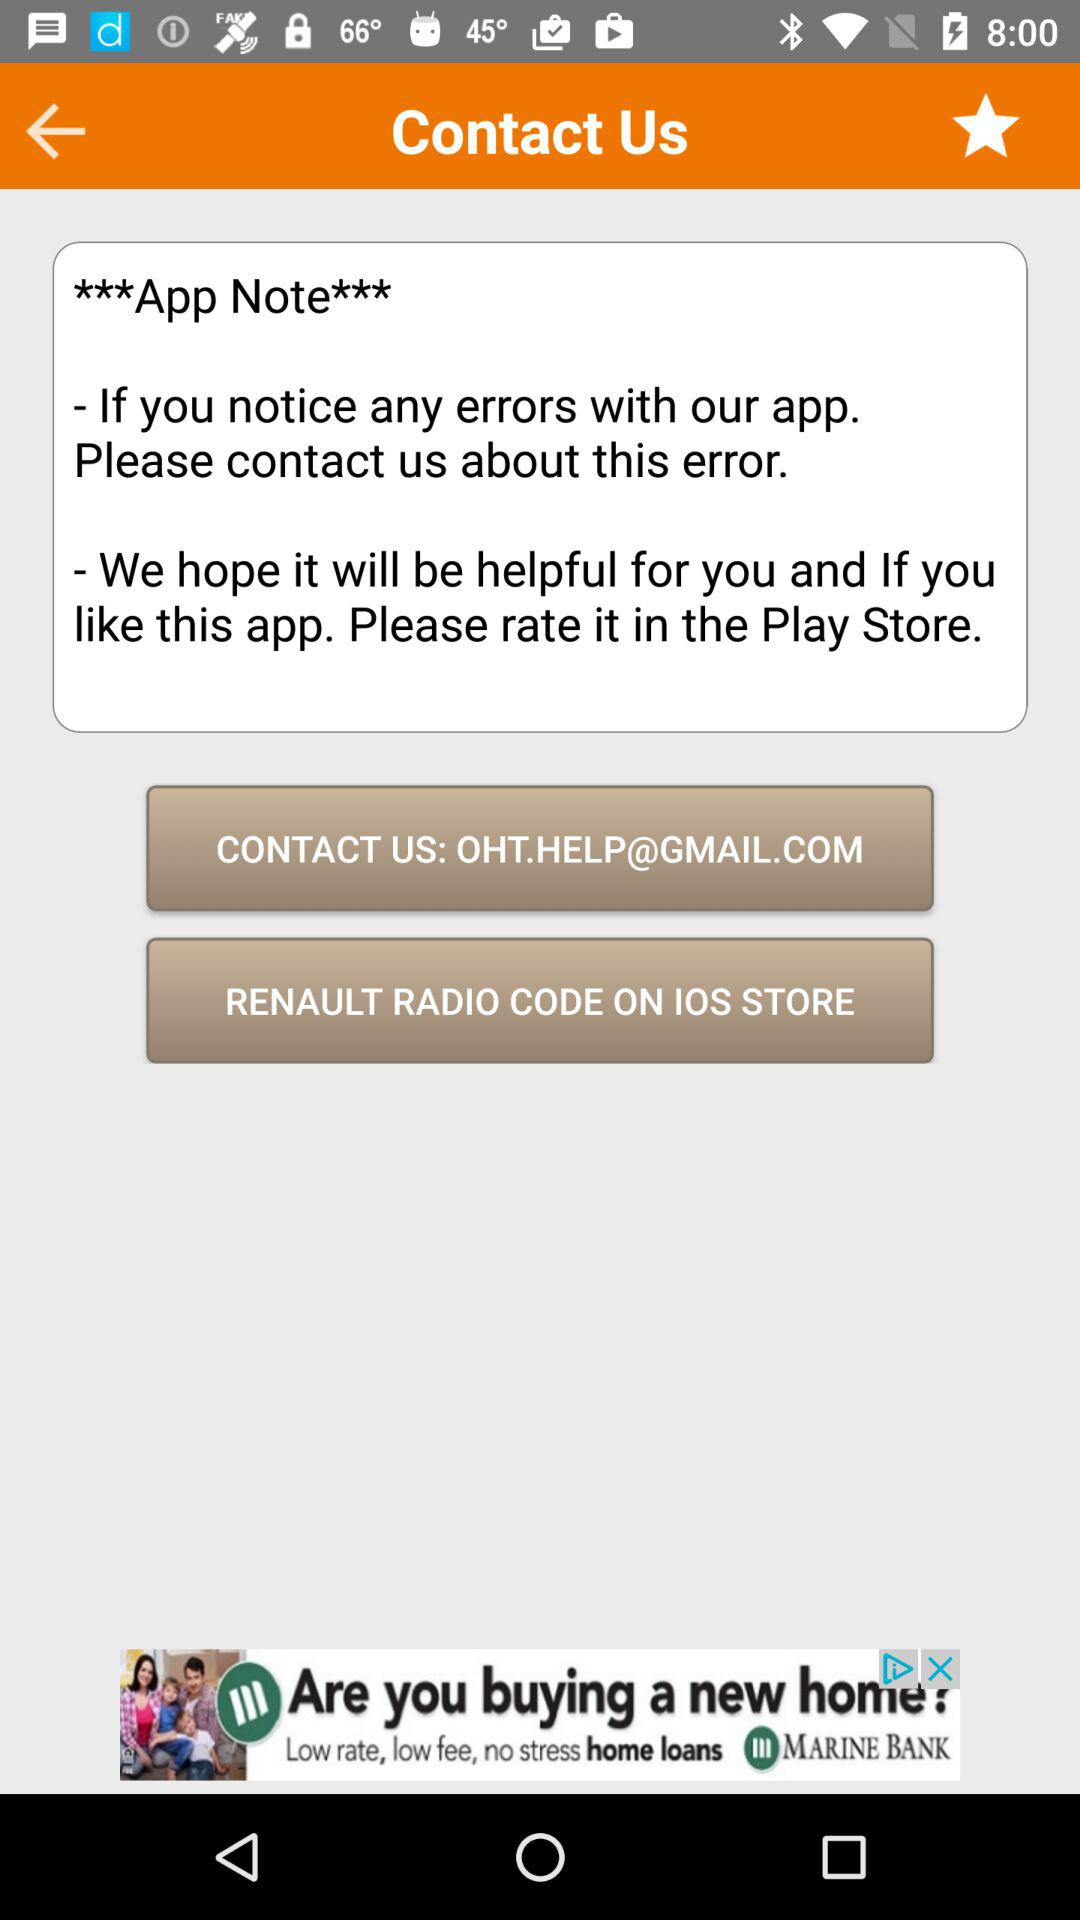What is the contact email id? The contact email ID is OHT.HELP@GMAIL.COM. 